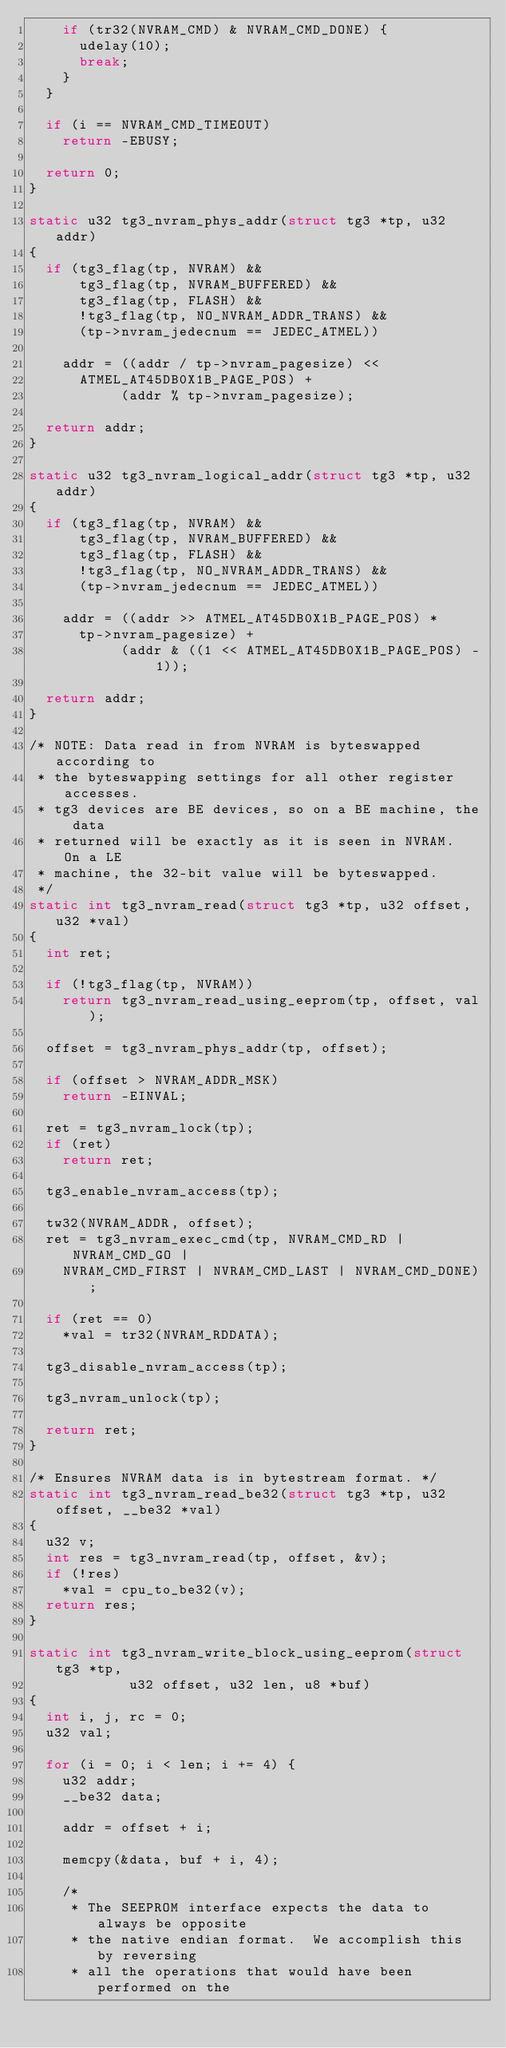Convert code to text. <code><loc_0><loc_0><loc_500><loc_500><_C_>		if (tr32(NVRAM_CMD) & NVRAM_CMD_DONE) {
			udelay(10);
			break;
		}
	}

	if (i == NVRAM_CMD_TIMEOUT)
		return -EBUSY;

	return 0;
}

static u32 tg3_nvram_phys_addr(struct tg3 *tp, u32 addr)
{
	if (tg3_flag(tp, NVRAM) &&
	    tg3_flag(tp, NVRAM_BUFFERED) &&
	    tg3_flag(tp, FLASH) &&
	    !tg3_flag(tp, NO_NVRAM_ADDR_TRANS) &&
	    (tp->nvram_jedecnum == JEDEC_ATMEL))

		addr = ((addr / tp->nvram_pagesize) <<
			ATMEL_AT45DB0X1B_PAGE_POS) +
		       (addr % tp->nvram_pagesize);

	return addr;
}

static u32 tg3_nvram_logical_addr(struct tg3 *tp, u32 addr)
{
	if (tg3_flag(tp, NVRAM) &&
	    tg3_flag(tp, NVRAM_BUFFERED) &&
	    tg3_flag(tp, FLASH) &&
	    !tg3_flag(tp, NO_NVRAM_ADDR_TRANS) &&
	    (tp->nvram_jedecnum == JEDEC_ATMEL))

		addr = ((addr >> ATMEL_AT45DB0X1B_PAGE_POS) *
			tp->nvram_pagesize) +
		       (addr & ((1 << ATMEL_AT45DB0X1B_PAGE_POS) - 1));

	return addr;
}

/* NOTE: Data read in from NVRAM is byteswapped according to
 * the byteswapping settings for all other register accesses.
 * tg3 devices are BE devices, so on a BE machine, the data
 * returned will be exactly as it is seen in NVRAM.  On a LE
 * machine, the 32-bit value will be byteswapped.
 */
static int tg3_nvram_read(struct tg3 *tp, u32 offset, u32 *val)
{
	int ret;

	if (!tg3_flag(tp, NVRAM))
		return tg3_nvram_read_using_eeprom(tp, offset, val);

	offset = tg3_nvram_phys_addr(tp, offset);

	if (offset > NVRAM_ADDR_MSK)
		return -EINVAL;

	ret = tg3_nvram_lock(tp);
	if (ret)
		return ret;

	tg3_enable_nvram_access(tp);

	tw32(NVRAM_ADDR, offset);
	ret = tg3_nvram_exec_cmd(tp, NVRAM_CMD_RD | NVRAM_CMD_GO |
		NVRAM_CMD_FIRST | NVRAM_CMD_LAST | NVRAM_CMD_DONE);

	if (ret == 0)
		*val = tr32(NVRAM_RDDATA);

	tg3_disable_nvram_access(tp);

	tg3_nvram_unlock(tp);

	return ret;
}

/* Ensures NVRAM data is in bytestream format. */
static int tg3_nvram_read_be32(struct tg3 *tp, u32 offset, __be32 *val)
{
	u32 v;
	int res = tg3_nvram_read(tp, offset, &v);
	if (!res)
		*val = cpu_to_be32(v);
	return res;
}

static int tg3_nvram_write_block_using_eeprom(struct tg3 *tp,
				    u32 offset, u32 len, u8 *buf)
{
	int i, j, rc = 0;
	u32 val;

	for (i = 0; i < len; i += 4) {
		u32 addr;
		__be32 data;

		addr = offset + i;

		memcpy(&data, buf + i, 4);

		/*
		 * The SEEPROM interface expects the data to always be opposite
		 * the native endian format.  We accomplish this by reversing
		 * all the operations that would have been performed on the</code> 